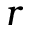<formula> <loc_0><loc_0><loc_500><loc_500>r</formula> 